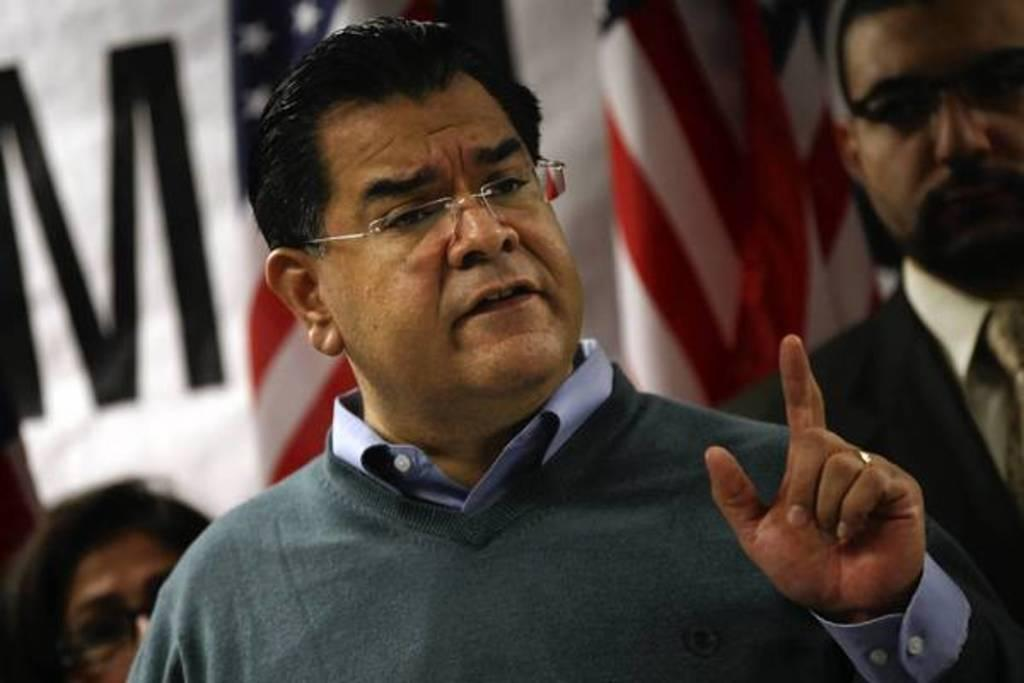Who can be seen in the image? There are people in the image. Can you describe the man in the middle of the image? The man in the middle of the image is wearing spectacles. What can be seen in the background of the image? There are flags in the background of the image. What type of cushion is the man using to sleep in the image? There is no cushion or indication of the man sleeping in the image. 